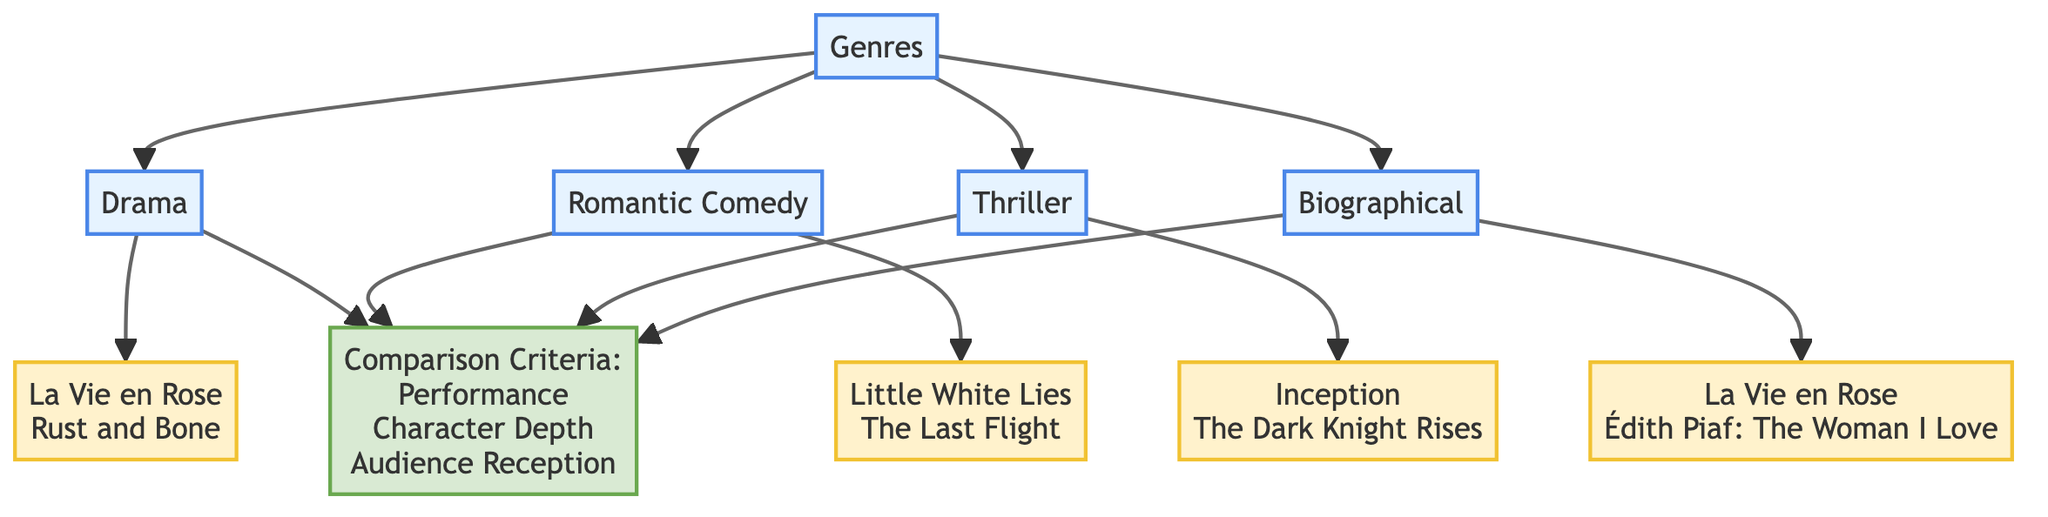What are the film genres represented in the chart? The diagram lists four film genres connected to Marion Cotillard's roles: Drama, Romantic Comedy, Thriller, and Biographical. These genres are visible directly under the "Genres" node, showcasing the different categories of her performances.
Answer: Drama, Romantic Comedy, Thriller, Biographical Which genre includes "Inception"? "Inception" is categorized under the Thriller genre, as indicated by the connection from the Thriller node to the films listed. The flow from the node for Thriller directs to the node listing key films, confirming this association.
Answer: Thriller How many key films are listed for the Drama genre? There are two key films listed under the Drama genre: "La Vie en Rose" and "Rust and Bone". This is derived from the linking of the Drama node to its respective film node and counting the titles provided there.
Answer: 2 What criteria are used for comparison? The comparison criteria listed in the chart include Performance, Character Depth, and Audience Reception. This information is located in the node labeled "Comparison Criteria", which branches from all the genre nodes, indicating applicable aspects for comparison across genres.
Answer: Performance, Character Depth, Audience Reception Which film appears under both the Drama and Biographical genres? "La Vie en Rose" is the film that appears under both the Drama and Biographical genres. It is specifically mentioned as a key film in both the Drama and Biographical nodes, illustrating its dual categorization.
Answer: La Vie en Rose What is the total number of nodes in the diagram? The total number of nodes in the diagram is ten, as counted from the initial description which enumerates the elements, including genres, key films, and comparison criteria. Thus, by simply counting all unique entries connected within the flowchart, the total comes to ten.
Answer: 10 